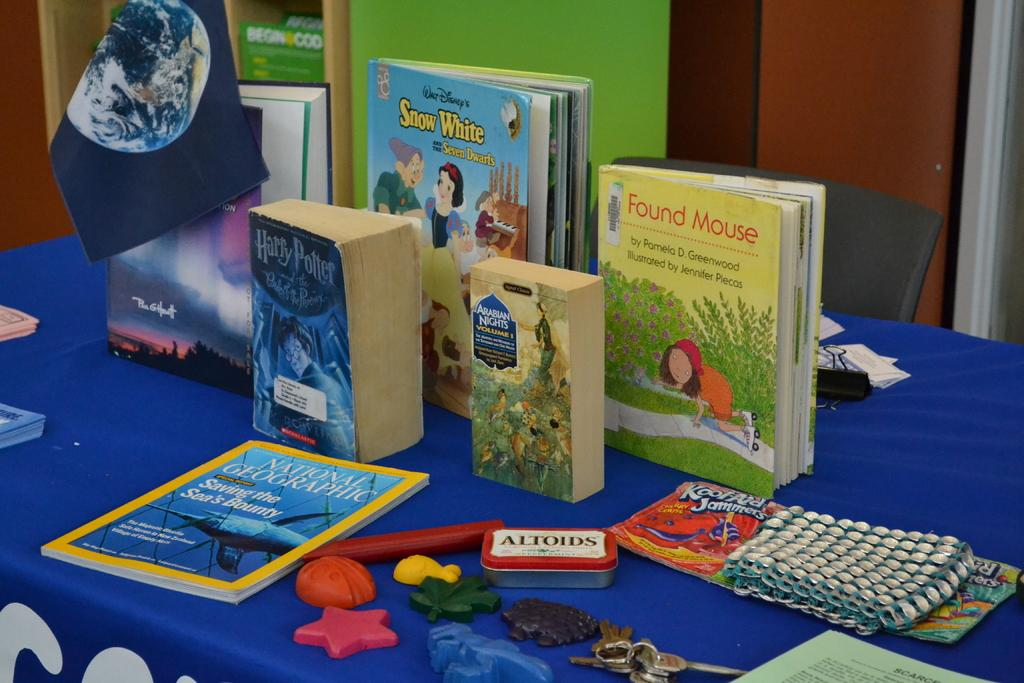<image>
Provide a brief description of the given image. A table with a blue tablecloth on it has children's books on it including Harry Potter. 